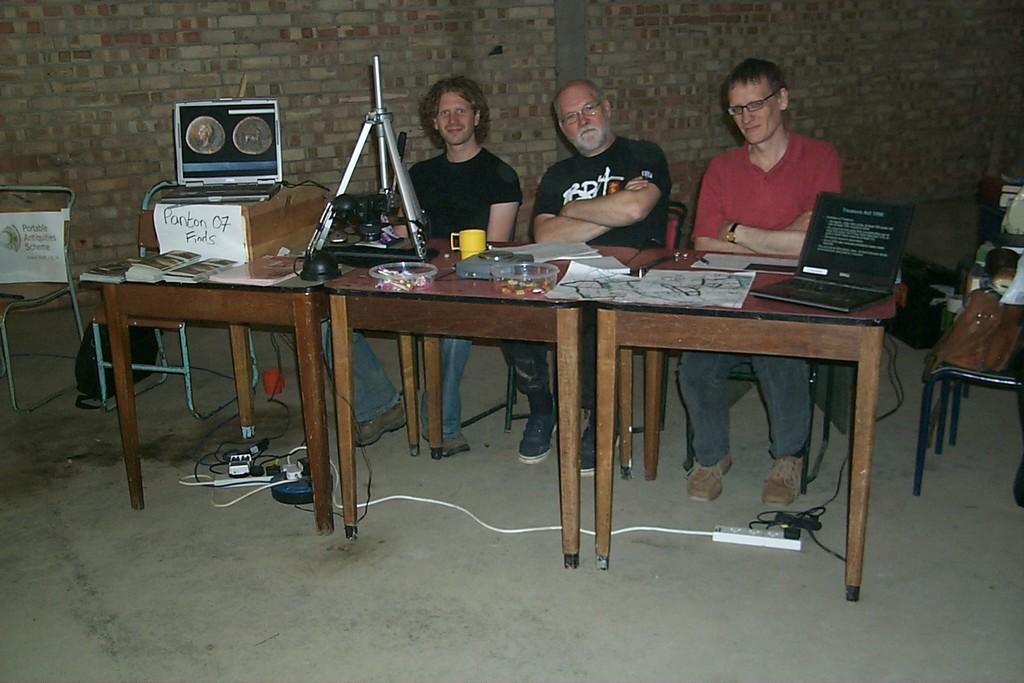How would you summarize this image in a sentence or two? In this image there are three persons sitting on the chair in front of the table on which laptop, box, papers, pen, camera stand, books and soon kept. The background wall is of bricks. On the floor there are sockets and wires visible and boards visible. This image is taken inside a hall. 